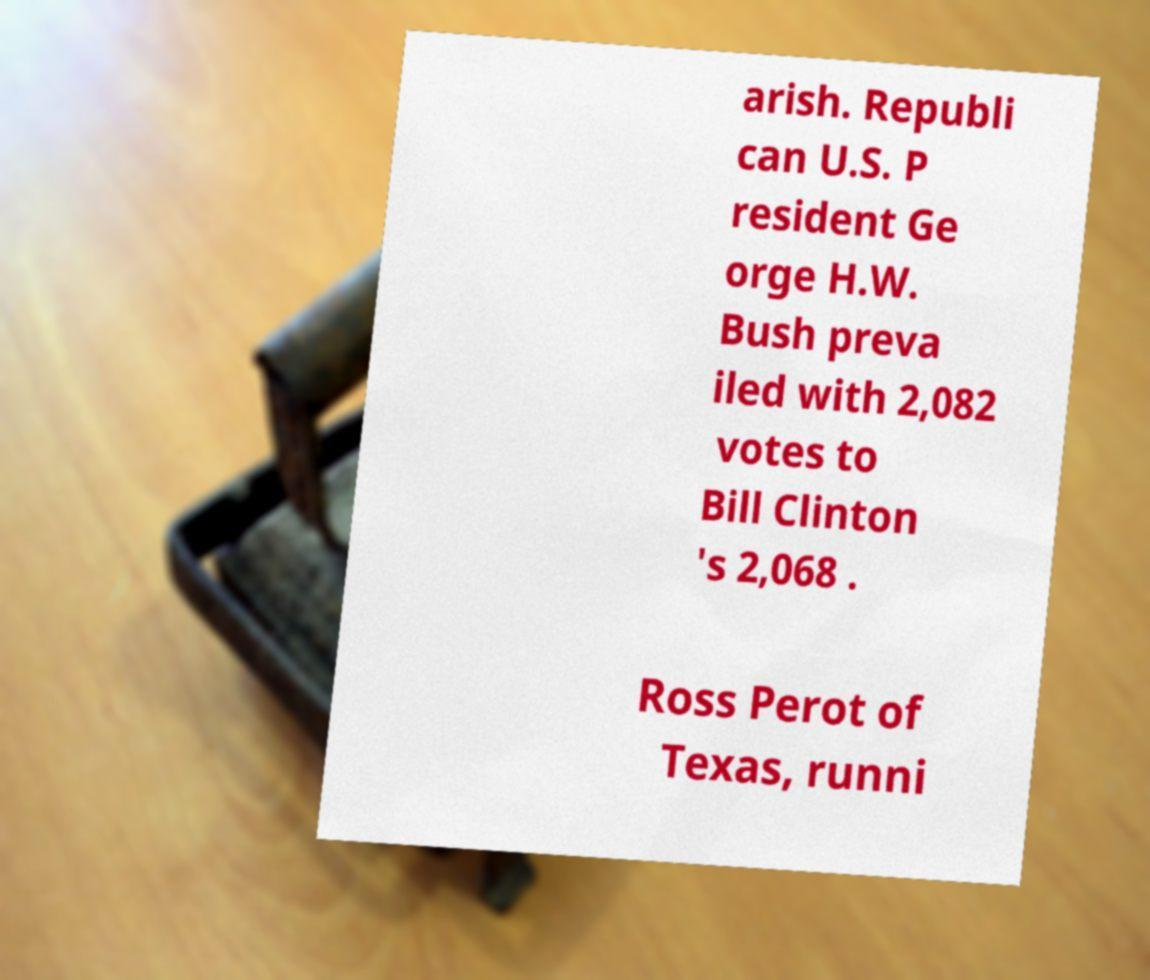For documentation purposes, I need the text within this image transcribed. Could you provide that? arish. Republi can U.S. P resident Ge orge H.W. Bush preva iled with 2,082 votes to Bill Clinton 's 2,068 . Ross Perot of Texas, runni 